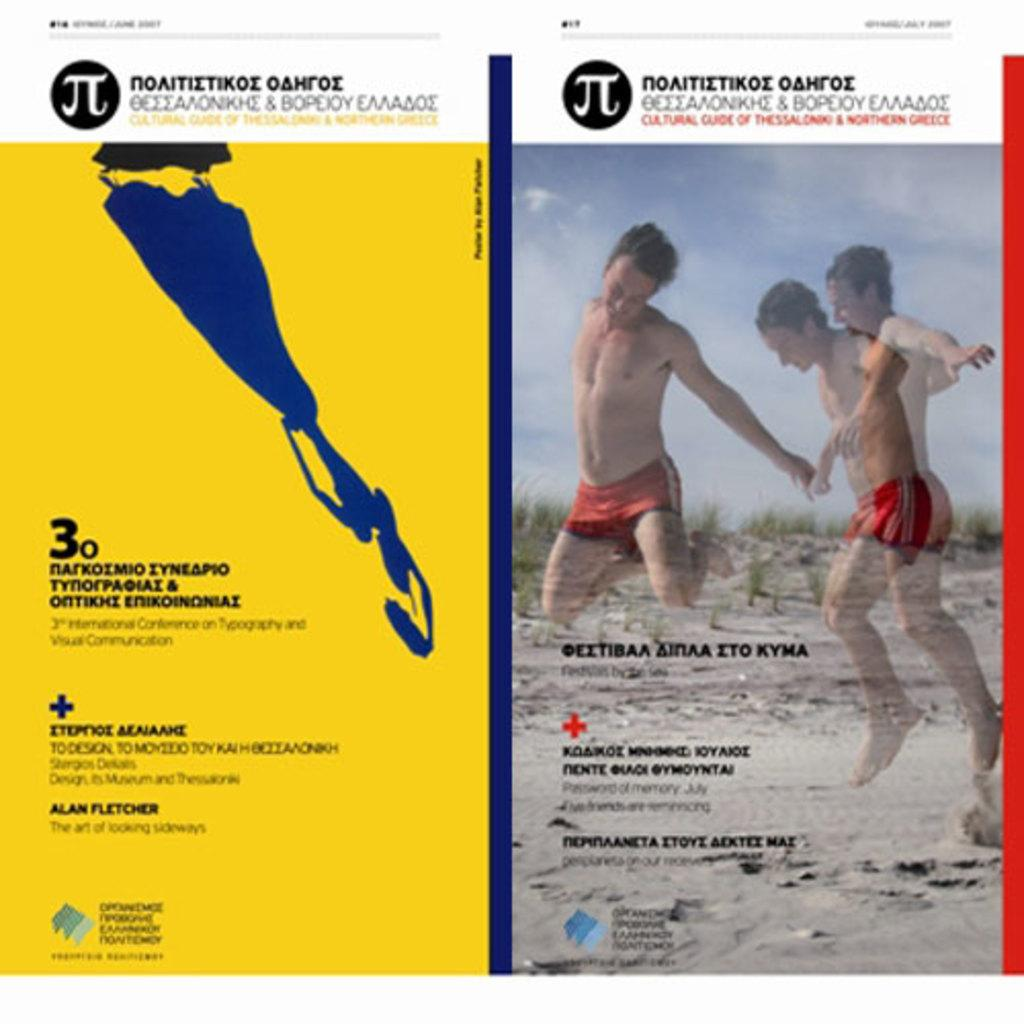What is featured in the image? There is a poster in the image. What can be found on the poster? The poster contains text and an image of two men who are jumping. What is visible in the background of the poster? There are plants in the background of the poster. Can you tell me how many women are present on the poster? There are no women present on the poster; it features two men who are jumping. What is the son of the man on the poster doing? There is no son of the man on the poster depicted in the image. 